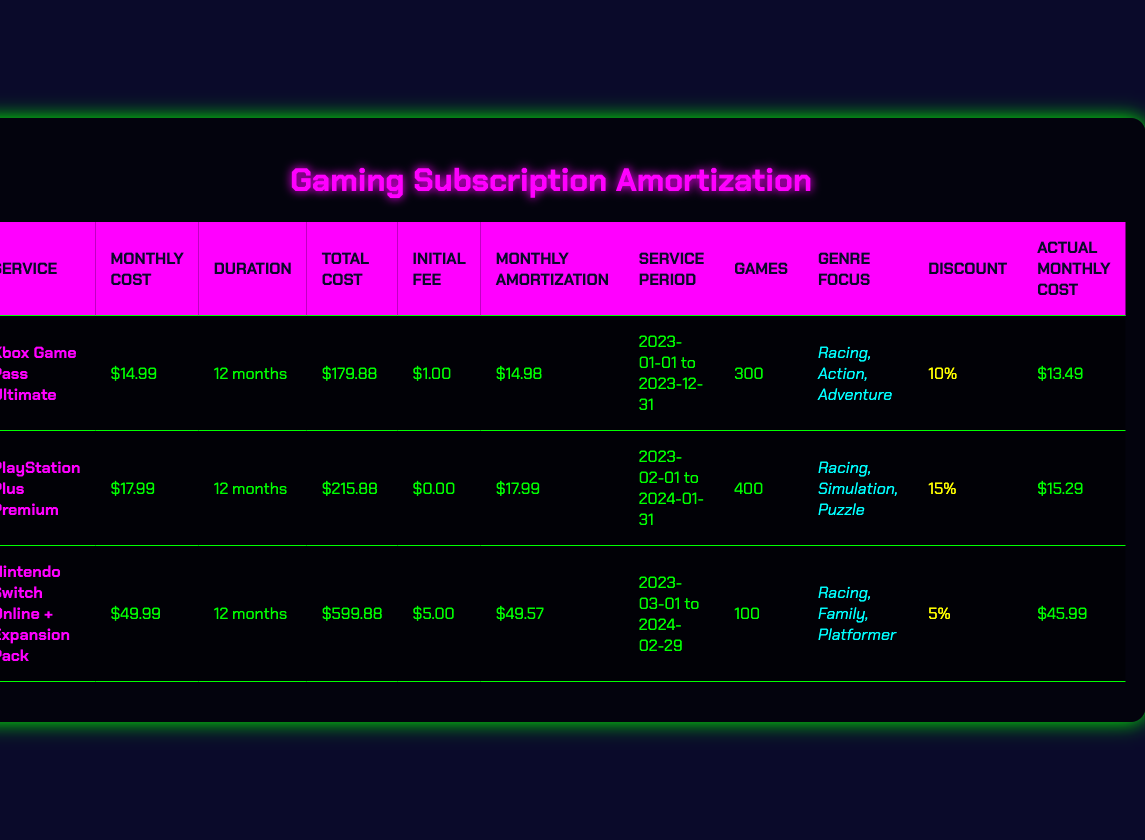What is the total cost of the Xbox Game Pass Ultimate subscription? The table lists the total cost for each subscription service. For Xbox Game Pass Ultimate, it states the total cost is $179.88.
Answer: 179.88 What is the initial fee for the PlayStation Plus Premium service? The initial fee is shown in the corresponding row for PlayStation Plus Premium. It indicates that the initial fee is $0.00.
Answer: 0.00 Which gaming subscription has the highest actual monthly cost after discount? To determine which has the highest actual monthly cost, compare the "Actual Monthly Cost" column for all services. The highest value is $45.99 for Nintendo Switch Online + Expansion Pack.
Answer: 45.99 How much is the average monthly amortization across all services? First, sum the monthly amortization values: (14.98 + 17.99 + 49.57) = 82.54. Then, divide by the number of services (3): 82.54 / 3 = 27.51.
Answer: 27.51 Is the discount applied to the Nintendo Switch Online + Expansion Pack service greater than the discount for Xbox Game Pass Ultimate? The discounts are listed for each service: Nintendo Switch Online + Expansion Pack has a 5% discount, while Xbox Game Pass Ultimate has a 10% discount. Since 10% > 5%, the answer is yes.
Answer: Yes What is the genre focus for the PlayStation Plus Premium subscription? The table indicates the genre focus for PlayStation Plus Premium is "Racing, Simulation, Puzzle."
Answer: Racing, Simulation, Puzzle Which subscription service offers the most games in its library? Check the "Games" column for each service. PlayStation Plus Premium has 400 games, which is the highest compared to others (300 and 100).
Answer: 400 If I want to save the most on a subscription, which one should I choose based on the actual monthly cost after discount? Analyze the "Actual Monthly Cost" column. The lowest actual monthly cost is $13.49 for Xbox Game Pass Ultimate, making it the best option for savings.
Answer: 13.49 Is the duration of all subscriptions equal? The duration for each subscription is listed as 12 months for Xbox Game Pass Ultimate and PlayStation Plus Premium, but Nintendo Switch Online + Expansion Pack is also for 12 months. Therefore, all have equal duration.
Answer: Yes 